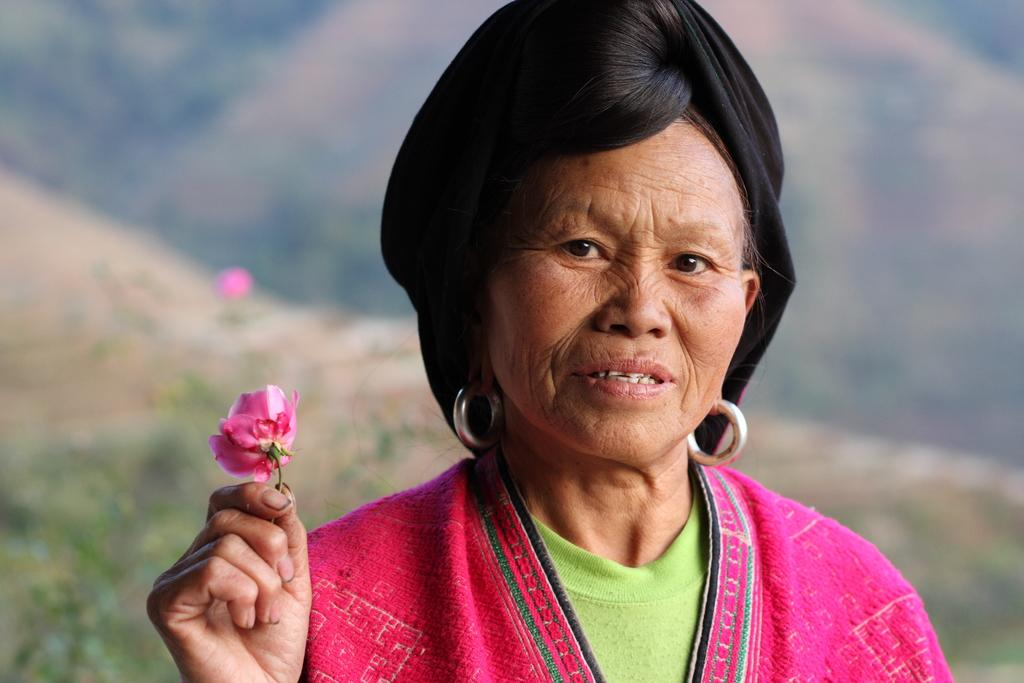Who is present in the image? There is a woman in the image. What is the woman holding in her hands? The woman is holding a flower in her hands. What can be seen in the distance behind the woman? There are hills visible in the background of the image. What type of crate is visible in the image? There is no crate present in the image. Can you tell me how many rods are being used by the woman in the image? The woman is not using any rods in the image; she is holding a flower. 